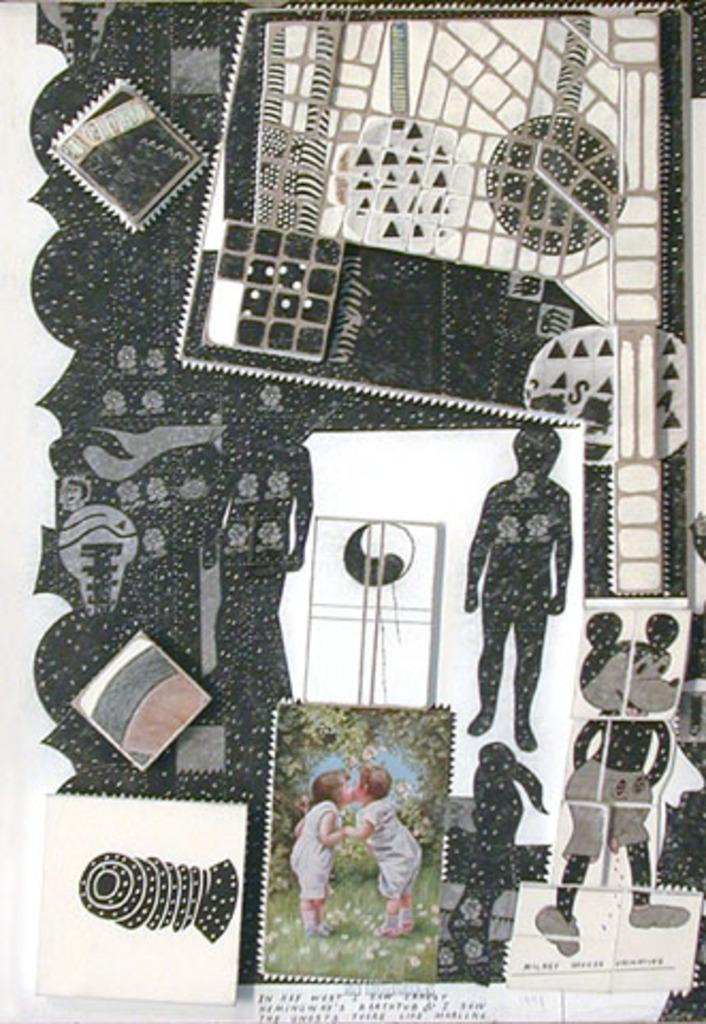What type of media is the image? The image is an animation. Who are the characters in the image? There is a boy and a girl in the image. Is there any text present in the image? Yes, there is text at the bottom of the image. What else can be seen in the image besides the characters? There are graphical images in the image. What type of plantation is shown in the image? There is no plantation present in the image; it is an animation featuring a boy and a girl with text and graphical images. What flavor of eggnog is the girl holding in the image? There is no eggnog present in the image; it is an animation with a boy and a girl, text, and graphical images. 